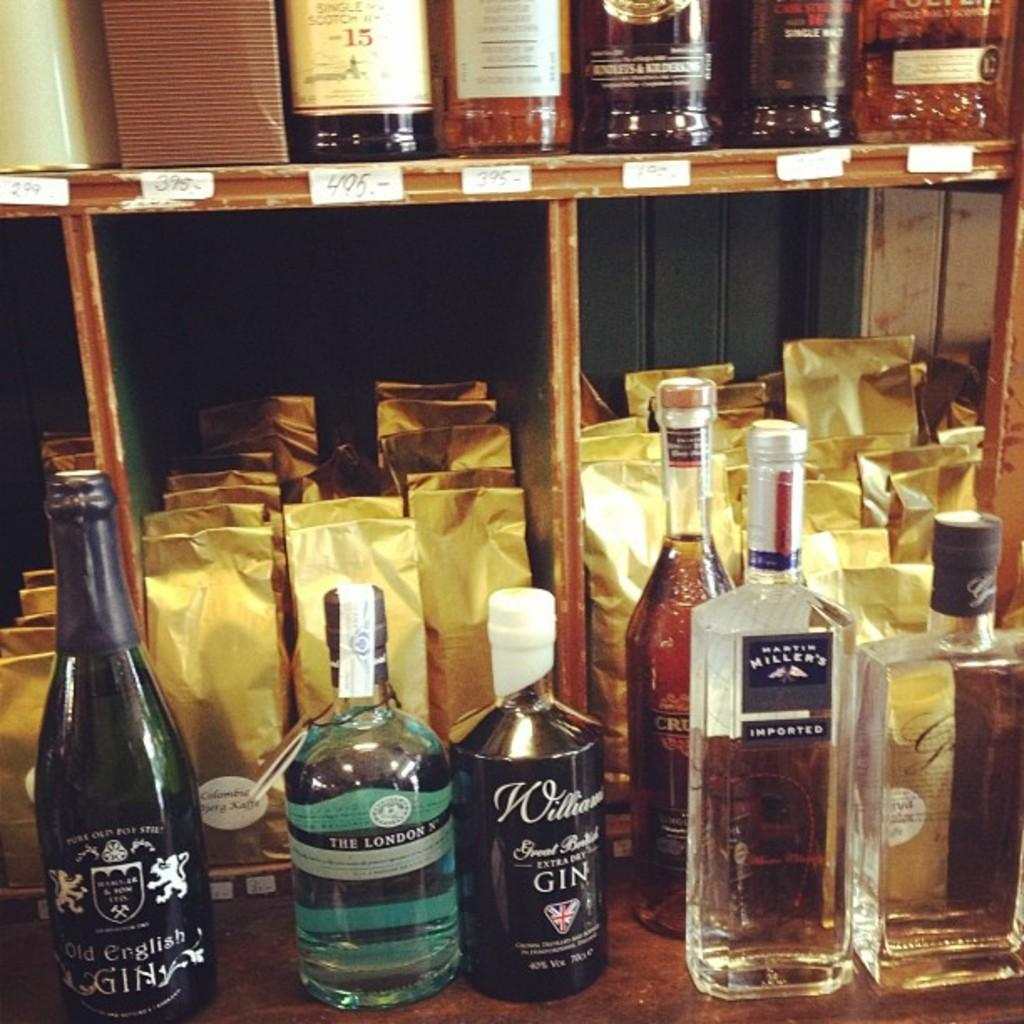Provide a one-sentence caption for the provided image. Liquor store with bottles of gin lined up in front. 